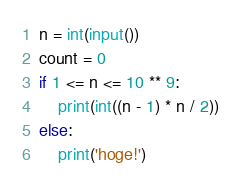<code> <loc_0><loc_0><loc_500><loc_500><_Python_>n = int(input())
count = 0
if 1 <= n <= 10 ** 9:
    print(int((n - 1) * n / 2))
else:
    print('hoge!')</code> 